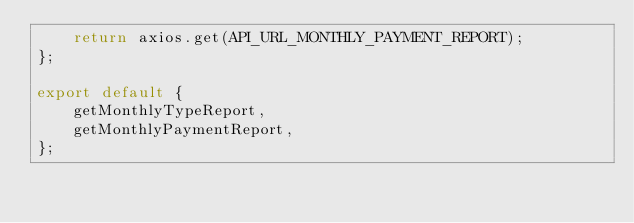<code> <loc_0><loc_0><loc_500><loc_500><_JavaScript_>    return axios.get(API_URL_MONTHLY_PAYMENT_REPORT);
};

export default {
    getMonthlyTypeReport,
    getMonthlyPaymentReport,
};

</code> 